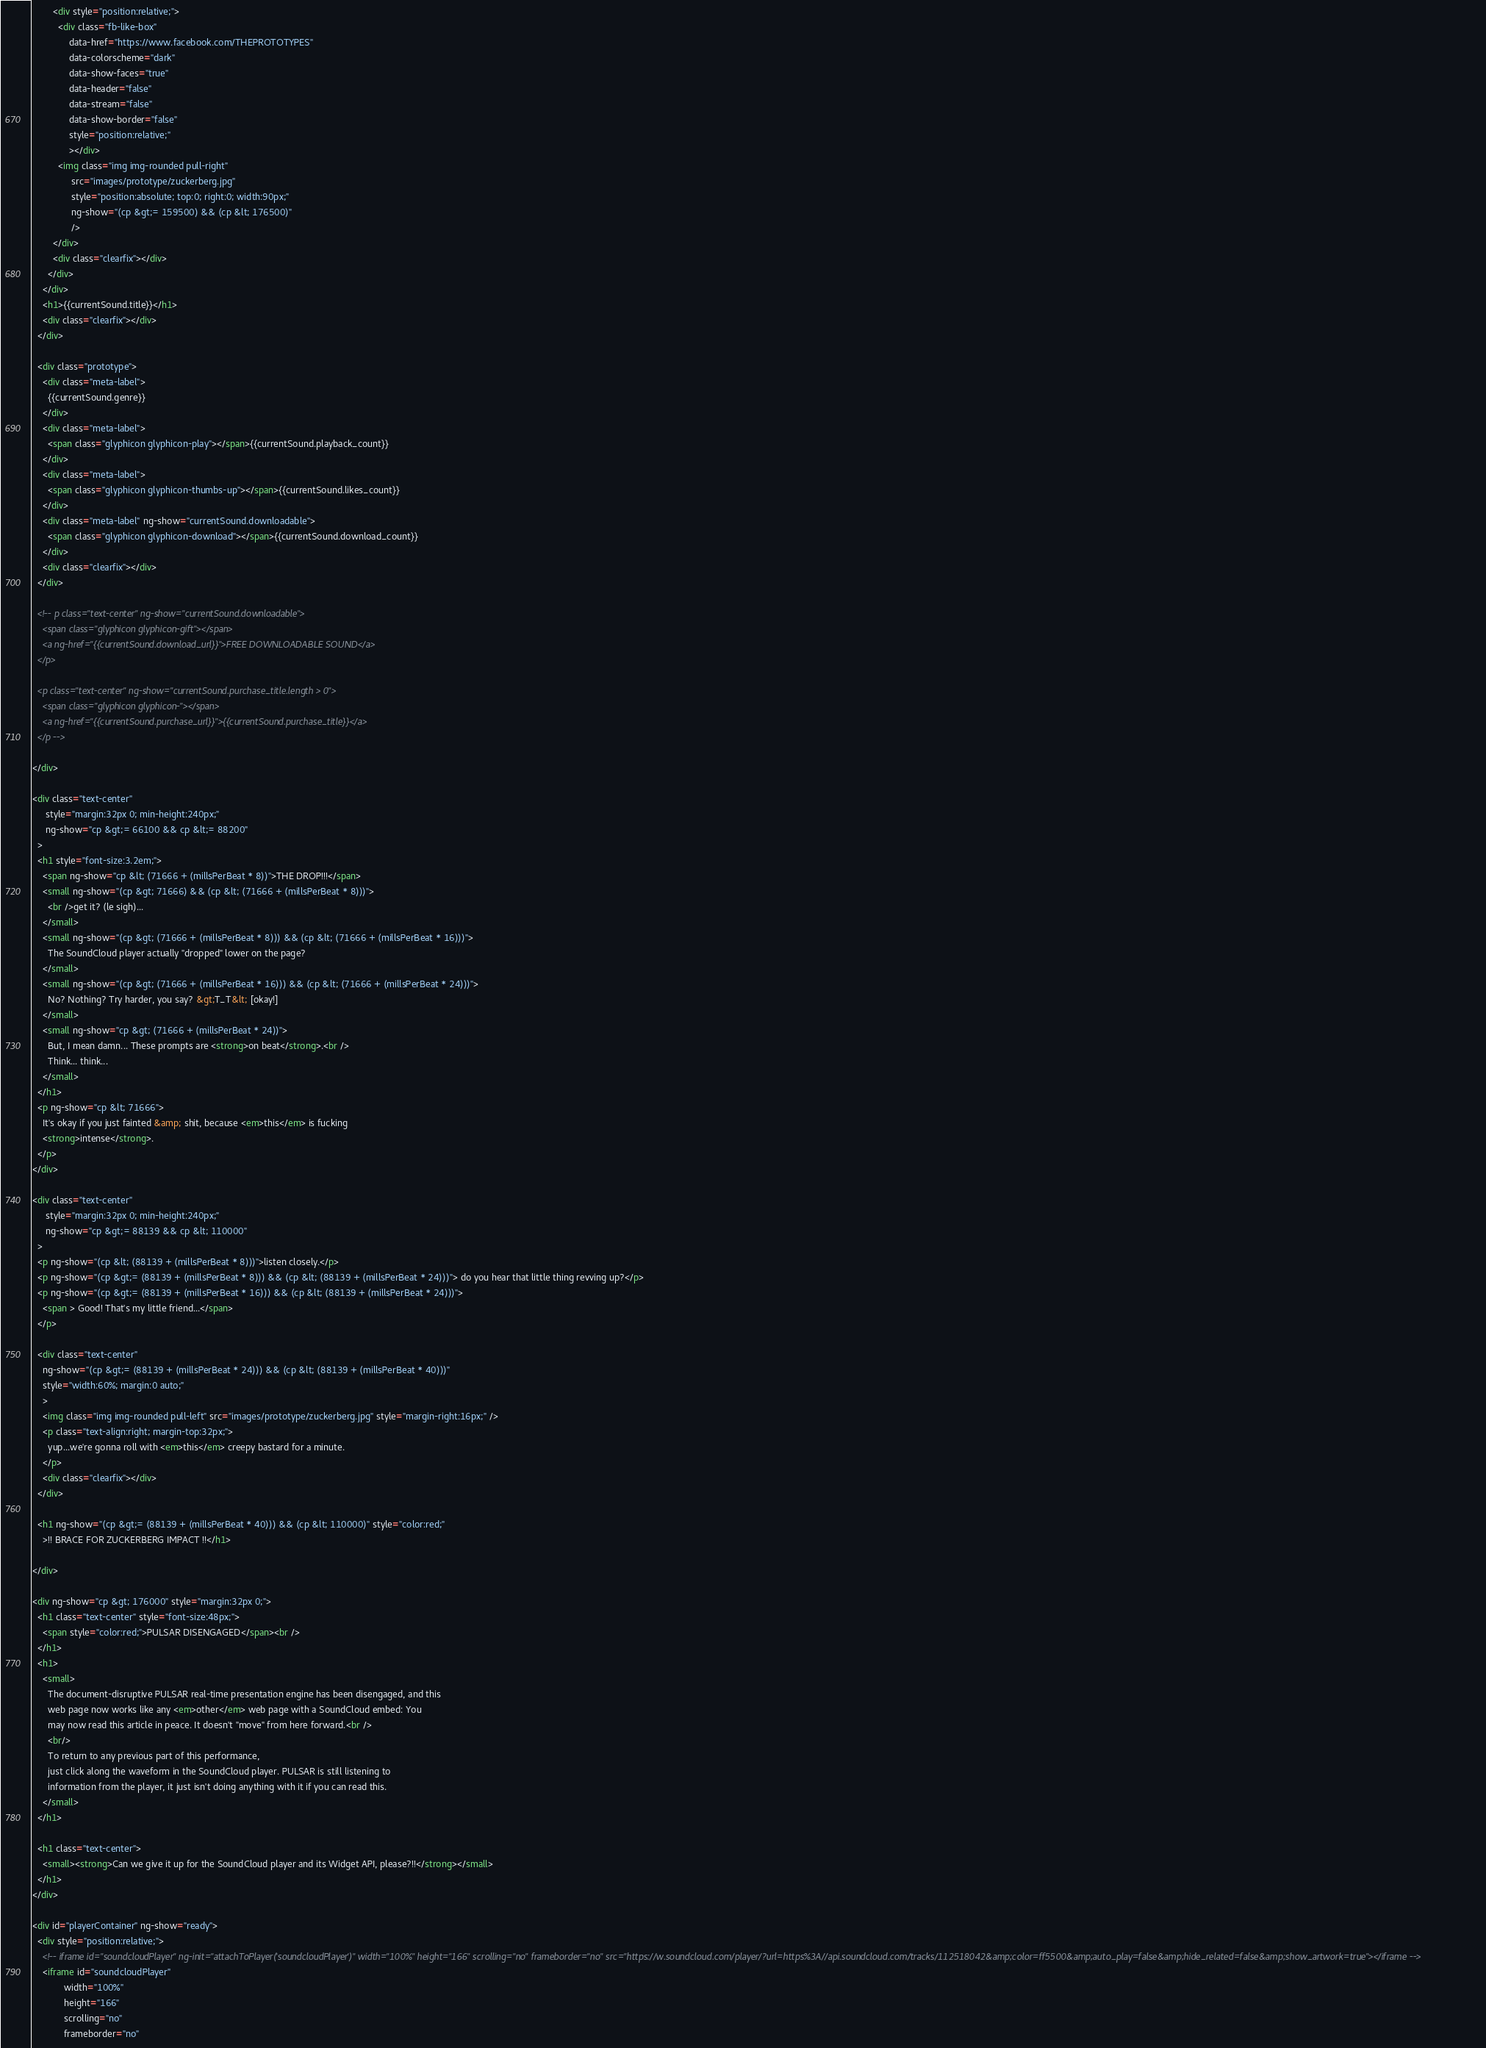<code> <loc_0><loc_0><loc_500><loc_500><_HTML_>        <div style="position:relative;">
          <div class="fb-like-box"
              data-href="https://www.facebook.com/THEPROTOTYPES"
              data-colorscheme="dark"
              data-show-faces="true"
              data-header="false"
              data-stream="false"
              data-show-border="false"
              style="position:relative;"
              ></div>
          <img class="img img-rounded pull-right"
               src="images/prototype/zuckerberg.jpg"
               style="position:absolute; top:0; right:0; width:90px;"
               ng-show="(cp &gt;= 159500) && (cp &lt; 176500)"
               />
        </div>
        <div class="clearfix"></div>
      </div>
    </div>
    <h1>{{currentSound.title}}</h1>
    <div class="clearfix"></div>
  </div>

  <div class="prototype">
    <div class="meta-label">
      {{currentSound.genre}}
    </div>
    <div class="meta-label">
      <span class="glyphicon glyphicon-play"></span>{{currentSound.playback_count}}
    </div>
    <div class="meta-label">
      <span class="glyphicon glyphicon-thumbs-up"></span>{{currentSound.likes_count}}
    </div>
    <div class="meta-label" ng-show="currentSound.downloadable">
      <span class="glyphicon glyphicon-download"></span>{{currentSound.download_count}}
    </div>
    <div class="clearfix"></div>
  </div>

  <!-- p class="text-center" ng-show="currentSound.downloadable">
    <span class="glyphicon glyphicon-gift"></span>
    <a ng-href="{{currentSound.download_url}}">FREE DOWNLOADABLE SOUND</a>
  </p>

  <p class="text-center" ng-show="currentSound.purchase_title.length > 0">
    <span class="glyphicon glyphicon-"></span>
    <a ng-href="{{currentSound.purchase_url}}">{{currentSound.purchase_title}}</a>
  </p -->

</div>

<div class="text-center"
     style="margin:32px 0; min-height:240px;"
     ng-show="cp &gt;= 66100 && cp &lt;= 88200"
  >
  <h1 style="font-size:3.2em;">
    <span ng-show="cp &lt; (71666 + (millsPerBeat * 8))">THE DROP!!!</span>
    <small ng-show="(cp &gt; 71666) && (cp &lt; (71666 + (millsPerBeat * 8)))">
      <br />get it? (le sigh)...
    </small>
    <small ng-show="(cp &gt; (71666 + (millsPerBeat * 8))) && (cp &lt; (71666 + (millsPerBeat * 16)))">
      The SoundCloud player actually "dropped" lower on the page?
    </small>
    <small ng-show="(cp &gt; (71666 + (millsPerBeat * 16))) && (cp &lt; (71666 + (millsPerBeat * 24)))">
      No? Nothing? Try harder, you say? &gt;T_T&lt; [okay!]
    </small>
    <small ng-show="cp &gt; (71666 + (millsPerBeat * 24))">
      But, I mean damn... These prompts are <strong>on beat</strong>.<br />
      Think... think...
    </small>
  </h1>
  <p ng-show="cp &lt; 71666">
    It's okay if you just fainted &amp; shit, because <em>this</em> is fucking
    <strong>intense</strong>.
  </p>
</div>

<div class="text-center"
     style="margin:32px 0; min-height:240px;"
     ng-show="cp &gt;= 88139 && cp &lt; 110000"
  >
  <p ng-show="(cp &lt; (88139 + (millsPerBeat * 8)))">listen closely.</p>
  <p ng-show="(cp &gt;= (88139 + (millsPerBeat * 8))) && (cp &lt; (88139 + (millsPerBeat * 24)))"> do you hear that little thing revving up?</p>
  <p ng-show="(cp &gt;= (88139 + (millsPerBeat * 16))) && (cp &lt; (88139 + (millsPerBeat * 24)))">
    <span > Good! That's my little friend...</span>
  </p>

  <div class="text-center"
    ng-show="(cp &gt;= (88139 + (millsPerBeat * 24))) && (cp &lt; (88139 + (millsPerBeat * 40)))"
    style="width:60%; margin:0 auto;"
    >
    <img class="img img-rounded pull-left" src="images/prototype/zuckerberg.jpg" style="margin-right:16px;" />
    <p class="text-align:right; margin-top:32px;">
      yup...we're gonna roll with <em>this</em> creepy bastard for a minute.
    </p>
    <div class="clearfix"></div>
  </div>

  <h1 ng-show="(cp &gt;= (88139 + (millsPerBeat * 40))) && (cp &lt; 110000)" style="color:red;"
    >!! BRACE FOR ZUCKERBERG IMPACT !!</h1>

</div>

<div ng-show="cp &gt; 176000" style="margin:32px 0;">
  <h1 class="text-center" style="font-size:48px;">
    <span style="color:red;">PULSAR DISENGAGED</span><br />
  </h1>
  <h1>
    <small>
      The document-disruptive PULSAR real-time presentation engine has been disengaged, and this
      web page now works like any <em>other</em> web page with a SoundCloud embed: You
      may now read this article in peace. It doesn't "move" from here forward.<br />
      <br/>
      To return to any previous part of this performance,
      just click along the waveform in the SoundCloud player. PULSAR is still listening to
      information from the player, it just isn't doing anything with it if you can read this.
    </small>
  </h1>

  <h1 class="text-center">
    <small><strong>Can we give it up for the SoundCloud player and its Widget API, please?!!</strong></small>
  </h1>
</div>

<div id="playerContainer" ng-show="ready">
  <div style="position:relative;">
    <!-- iframe id="soundcloudPlayer" ng-init="attachToPlayer('soundcloudPlayer')" width="100%" height="166" scrolling="no" frameborder="no" src="https://w.soundcloud.com/player/?url=https%3A//api.soundcloud.com/tracks/112518042&amp;color=ff5500&amp;auto_play=false&amp;hide_related=false&amp;show_artwork=true"></iframe -->
    <iframe id="soundcloudPlayer"
            width="100%"
            height="166"
            scrolling="no"
            frameborder="no"</code> 